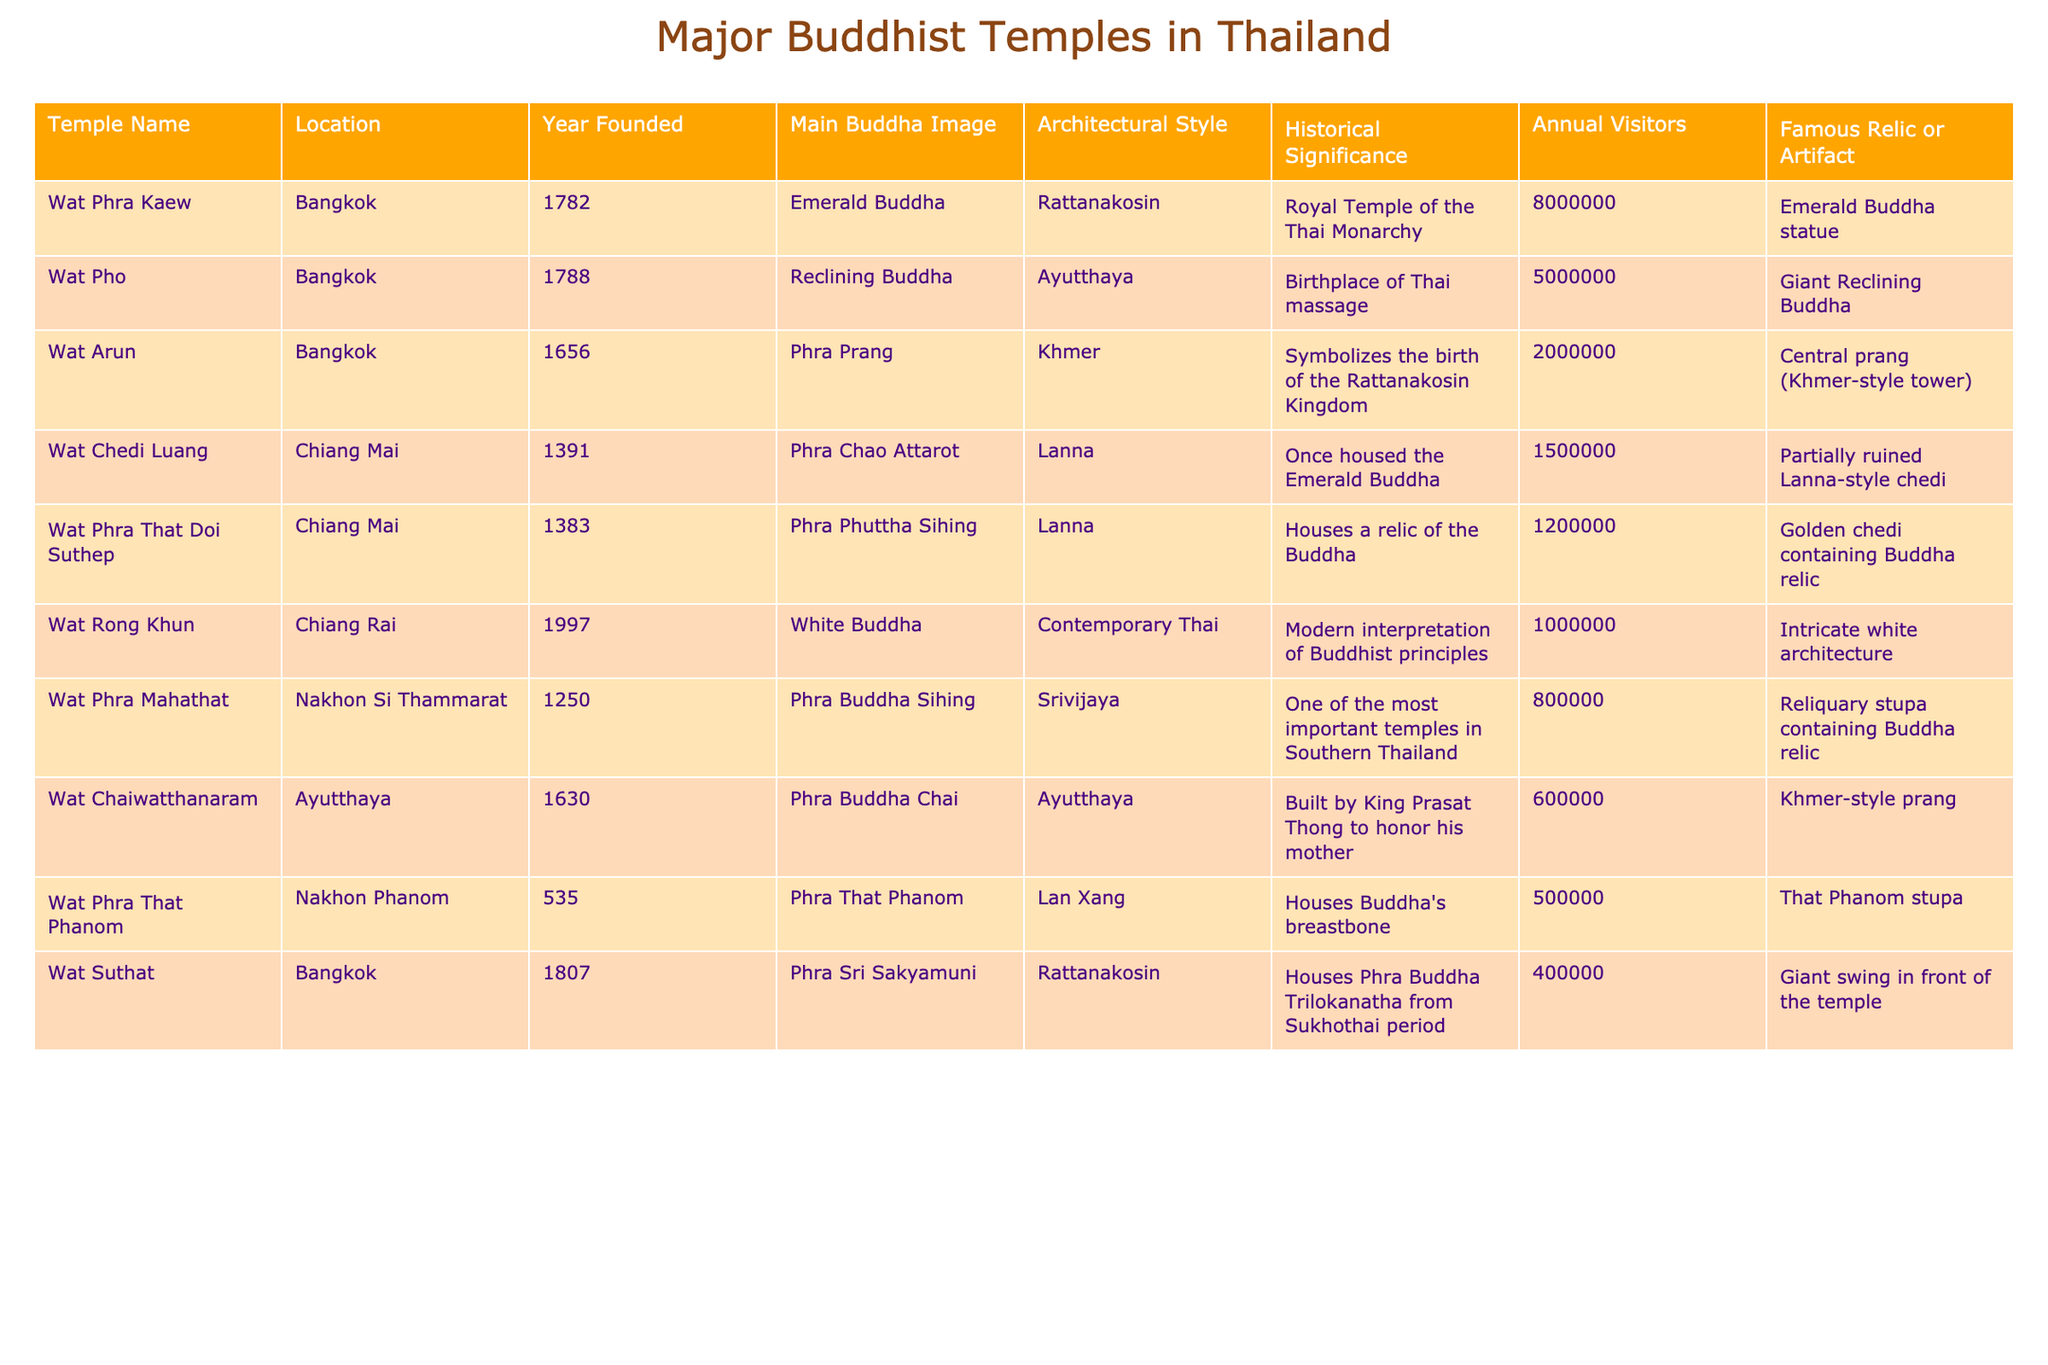What is the location of Wat Arun? The table directly states that Wat Arun is located in Bangkok.
Answer: Bangkok Which temple has the highest annual visitors? By comparing the annual visitors for all temples, Wat Phra Kaew has the highest with 8,000,000 visitors.
Answer: Wat Phra Kaew What year was Wat Pho founded? The table lists the founding year of Wat Pho as 1788.
Answer: 1788 Does Wat Phra That Doi Suthep house a relic of the Buddha? The table indicates that Wat Phra That Doi Suthep does house a relic of the Buddha, as marked in the historical significance section.
Answer: Yes Which architectural style is associated with Wat Chedi Luang? The table specifies that Wat Chedi Luang is built in the Lanna architectural style.
Answer: Lanna How many temples were founded before 1400? Wat Chedi Luang was founded in 1391, and Wat Phra That Doi Suthep in 1383, making a total of 2 temples founded before 1400.
Answer: 2 Which temple is known for its giant reclining Buddha? According to the table, Wat Pho is known for its giant reclining Buddha.
Answer: Wat Pho What is the main Buddha image of Wat Phra Mahathat? The main Buddha image of Wat Phra Mahathat is Phra Buddha Sihing as per the table.
Answer: Phra Buddha Sihing Which temple's annual visitors are closest to 1,500,000? By checking the annual visitors, Wat Chedi Luang with 1,500,000 visitors is closest to 1,500,000.
Answer: Wat Chedi Luang What is the significance of Wat Rong Khun as per the table? Wat Rong Khun is noted as a modern interpretation of Buddhist principles in the historical significance section.
Answer: Modern interpretation of Buddhist principles Which temple has a famous relic of Buddha's breastbone? The table shows that Wat Phra That Phanom houses the relic of Buddha's breastbone.
Answer: Wat Phra That Phanom What is the difference in annual visitors between Wat Phra Kaew and Wat Suhat? Wat Phra Kaew has 8,000,000 visitors, while Wat Suhat has 400,000. The difference is 8,000,000 - 400,000 = 7,600,000.
Answer: 7,600,000 Which temple is associated with Thai massage? The table indicates that Wat Pho is the birthplace of Thai massage.
Answer: Wat Pho What is the total number of annual visitors for the two temples founded in the 1700s? Wat Phra Kaew (8,000,000) and Wat Pho (5,000,000) were founded in the 1700s, leading to a total of 8,000,000 + 5,000,000 = 13,000,000.
Answer: 13,000,000 Is there a temple that symbolizes the birth of the Rattanakosin Kingdom? Yes, as indicated in the table, Wat Arun symbolizes the birth of the Rattanakosin Kingdom.
Answer: Yes Which temple is situated in Chiang Mai that was founded in the 1300s? The table shows that Wat Phra That Doi Suthep (1383) and Wat Chedi Luang (1391) are in Chiang Mai and founded in the 1300s.
Answer: Wat Phra That Doi Suthep and Wat Chedi Luang 